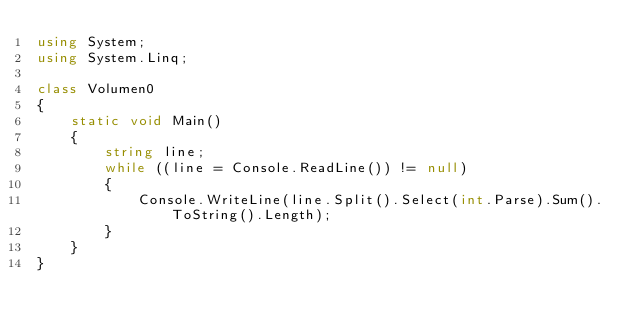<code> <loc_0><loc_0><loc_500><loc_500><_C#_>using System;
using System.Linq;

class Volumen0
{
    static void Main()
    {
        string line;
        while ((line = Console.ReadLine()) != null)
        {
            Console.WriteLine(line.Split().Select(int.Parse).Sum().ToString().Length);
        }
    }
}
</code> 